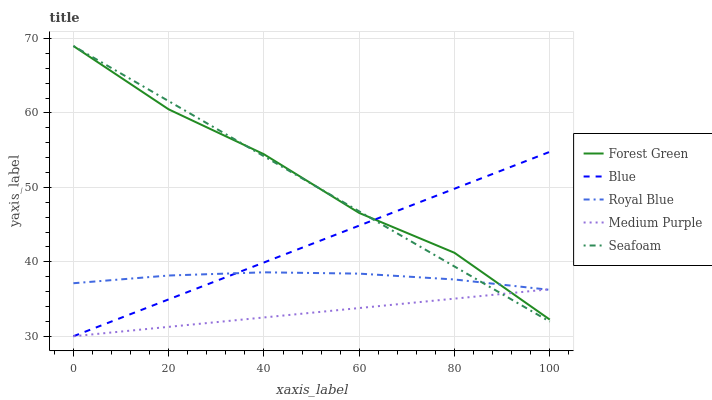Does Medium Purple have the minimum area under the curve?
Answer yes or no. Yes. Does Forest Green have the maximum area under the curve?
Answer yes or no. Yes. Does Royal Blue have the minimum area under the curve?
Answer yes or no. No. Does Royal Blue have the maximum area under the curve?
Answer yes or no. No. Is Medium Purple the smoothest?
Answer yes or no. Yes. Is Forest Green the roughest?
Answer yes or no. Yes. Is Royal Blue the smoothest?
Answer yes or no. No. Is Royal Blue the roughest?
Answer yes or no. No. Does Forest Green have the lowest value?
Answer yes or no. No. Does Royal Blue have the highest value?
Answer yes or no. No. 